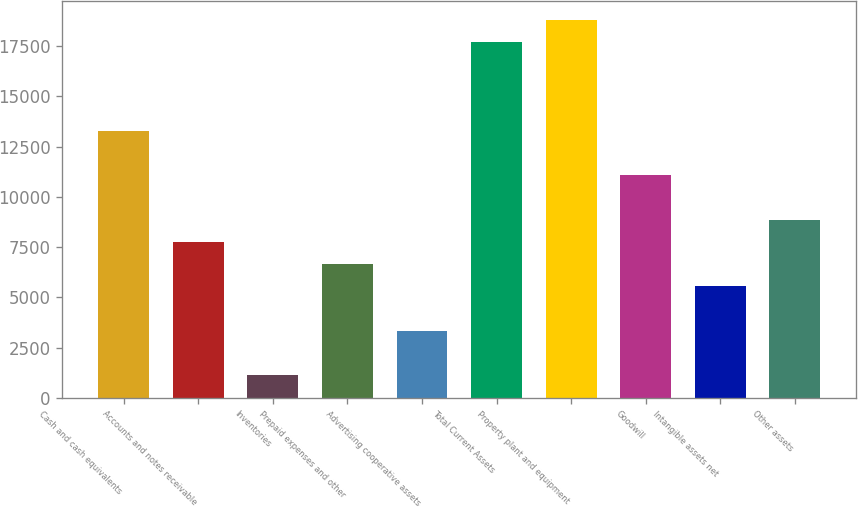Convert chart to OTSL. <chart><loc_0><loc_0><loc_500><loc_500><bar_chart><fcel>Cash and cash equivalents<fcel>Accounts and notes receivable<fcel>Inventories<fcel>Prepaid expenses and other<fcel>Advertising cooperative assets<fcel>Total Current Assets<fcel>Property plant and equipment<fcel>Goodwill<fcel>Intangible assets net<fcel>Other assets<nl><fcel>13274.4<fcel>7758.4<fcel>1139.2<fcel>6655.2<fcel>3345.6<fcel>17687.2<fcel>18790.4<fcel>11068<fcel>5552<fcel>8861.6<nl></chart> 